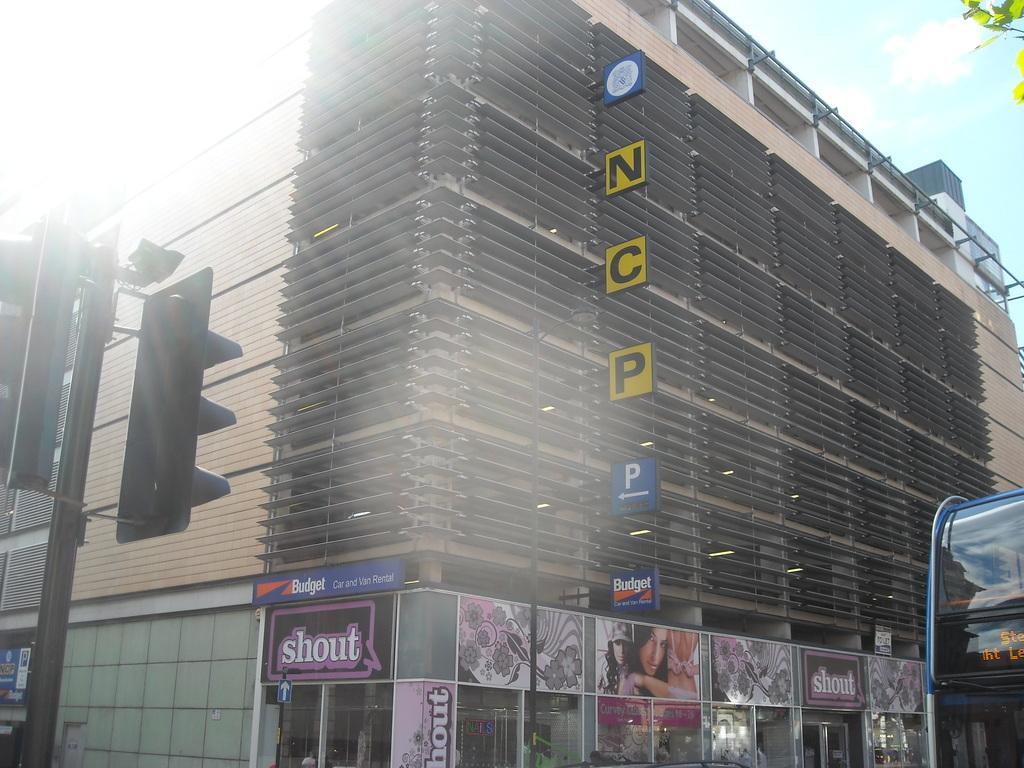Can you describe this image briefly? In this image there is a traffic signal in the left corner. There is vehicle and tree in the right corner. There is a building with some posters and text on it in the foreground. And there is a sky at the top. 